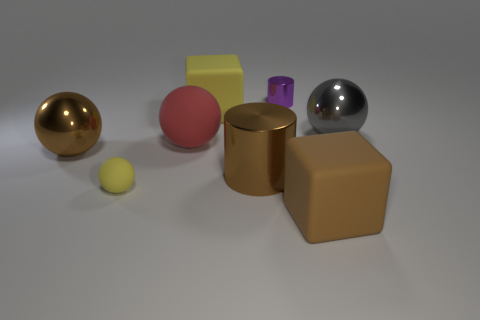Add 1 big gray rubber cubes. How many objects exist? 9 Subtract all brown spheres. How many spheres are left? 3 Subtract 2 cylinders. How many cylinders are left? 0 Subtract all yellow balls. How many balls are left? 3 Subtract 1 purple cylinders. How many objects are left? 7 Subtract all cylinders. How many objects are left? 6 Subtract all gray blocks. Subtract all brown cylinders. How many blocks are left? 2 Subtract all big objects. Subtract all tiny matte things. How many objects are left? 1 Add 2 metallic cylinders. How many metallic cylinders are left? 4 Add 1 gray matte cubes. How many gray matte cubes exist? 1 